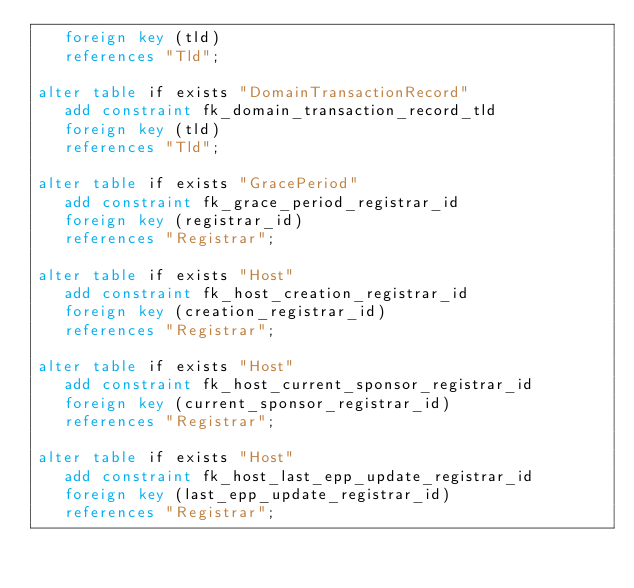<code> <loc_0><loc_0><loc_500><loc_500><_SQL_>   foreign key (tld)
   references "Tld";

alter table if exists "DomainTransactionRecord"
   add constraint fk_domain_transaction_record_tld
   foreign key (tld)
   references "Tld";

alter table if exists "GracePeriod"
   add constraint fk_grace_period_registrar_id
   foreign key (registrar_id)
   references "Registrar";

alter table if exists "Host"
   add constraint fk_host_creation_registrar_id
   foreign key (creation_registrar_id)
   references "Registrar";

alter table if exists "Host"
   add constraint fk_host_current_sponsor_registrar_id
   foreign key (current_sponsor_registrar_id)
   references "Registrar";

alter table if exists "Host"
   add constraint fk_host_last_epp_update_registrar_id
   foreign key (last_epp_update_registrar_id)
   references "Registrar";
</code> 